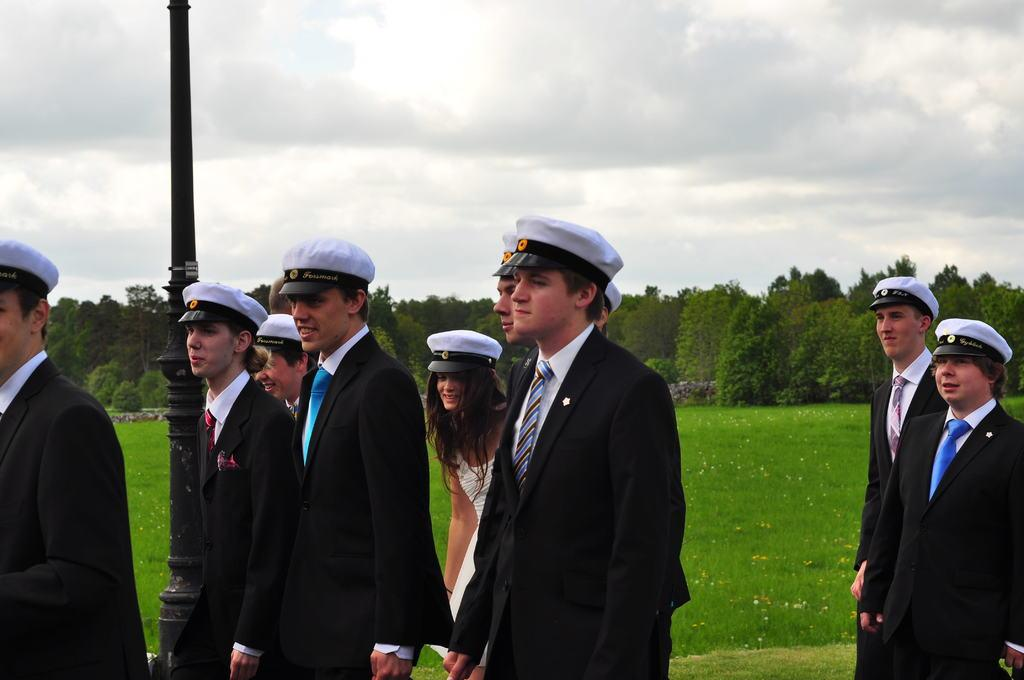What is the main subject of the image? The main subject of the image is a group of boys. What are the boys wearing in the image? The boys are wearing black coats and white navy caps. What expression do the boys have in the image? The boys are smiling in the image. What are the boys doing in the image? The boys are walking in the image. What can be seen in the background of the image? There is a grass lawn and trees visible in the background. What type of light can be seen reflecting off the boys' chins in the image? There is no mention of light reflecting off the boys' chins in the image, and their chins are not visible in the image. 